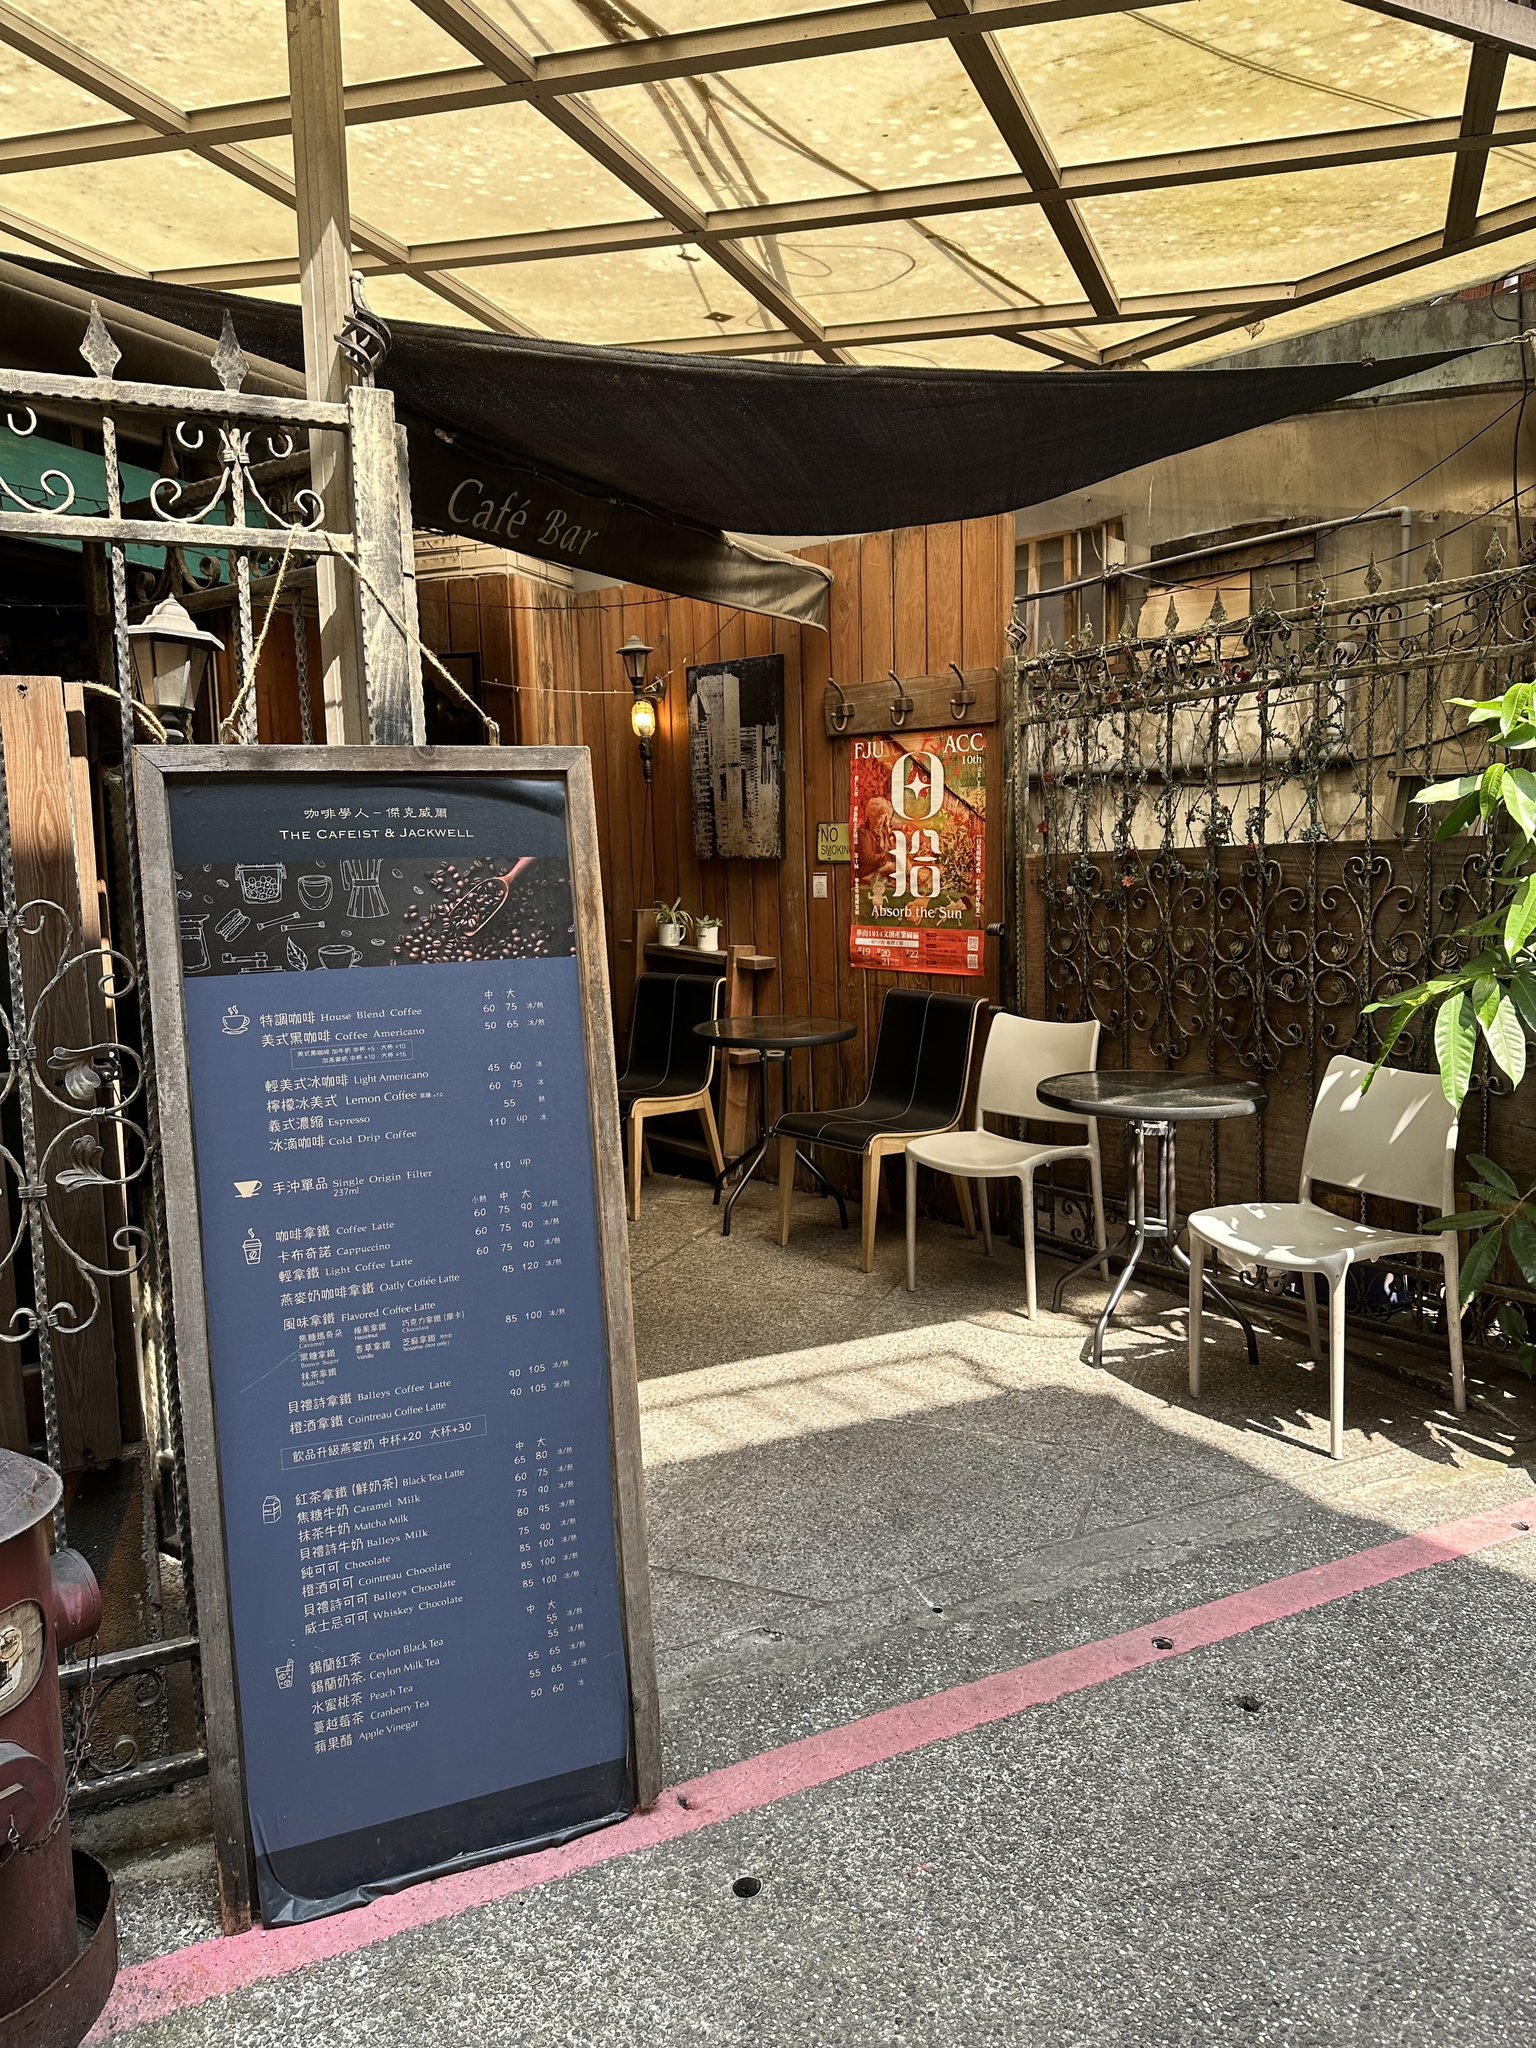How much does a medium hot latte cost? The medium hot latte costs 55 units of the currency listed on the menu. 